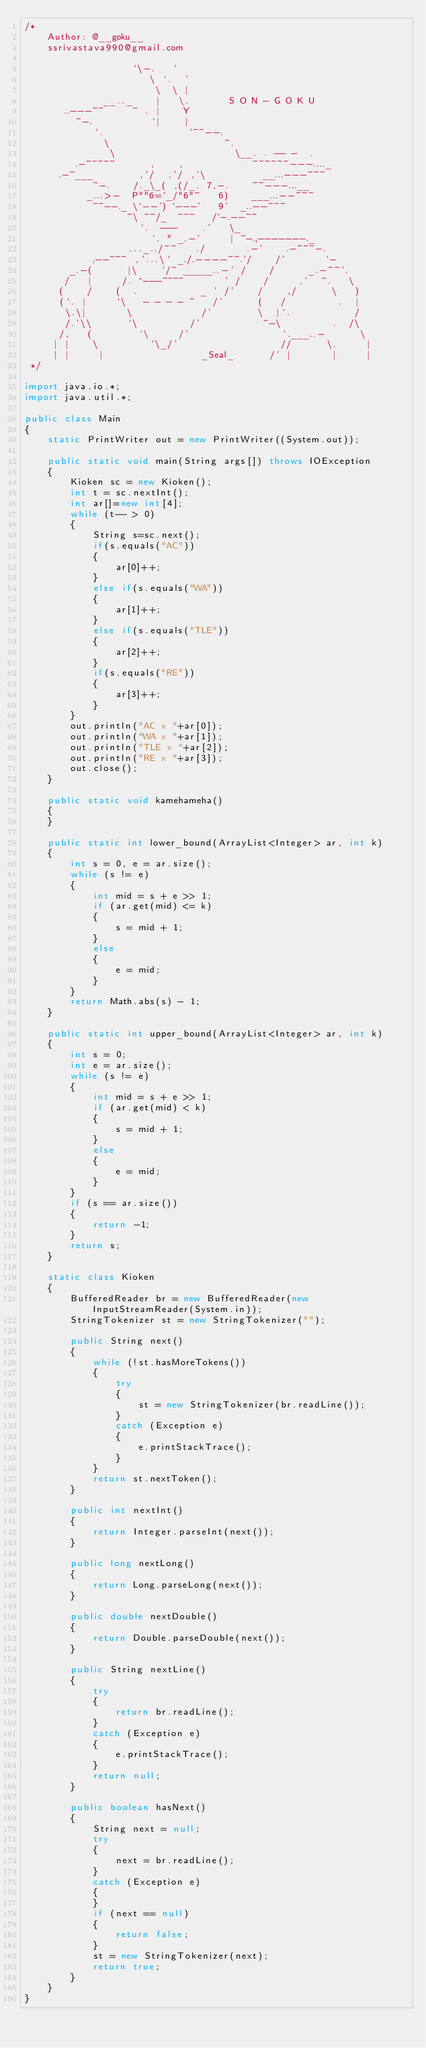Convert code to text. <code><loc_0><loc_0><loc_500><loc_500><_Java_>/*
    Author: @__goku__
    ssrivastava990@gmail.com

                   `\-.   `
                      \ `.  `
                       \  \ |
              __.._    |   \.       S O N - G O K U
       ..---~~     ~ . |    Y
         ~-.          `|    |
            `.               `~~--.
              \                    ~.
               \                     \__. . -- -  .
         .-~~~~~      ,    ,            ~~~~~~---...._
      .-~___        ,'/  ,'/ ,'\          __...---~~~
            ~-.    /._\_( ,(/_. 7,-.    ~~---...__
           _...>-  P""6=`_/"6"~   6)    ___...--~~~
            ~~--._ \`--') `---'   9'  _..--~~~
                  ~\ ~~/_  ~~~   /`-.--~~
                    `.  ---    .'   \_
                      `. " _.-'     | ~-.,-------._
                  ..._../~~   ./       .-'    .-~~~-.
            ,--~~~ ,'...\` _./.----~~.'/    /'       `-
        _.-(      |\    `/~ _____..-' /    /      _.-~~`.
       /   |     /. ^---~~~~       ' /    /     ,'  ~.   \
      (    /    (  .           _ ' /'    /    ,/      \   )
      (`. |     `\   - - - - ~   /'      (   /         .  |
       \.\|       \            /'        \  |`.           /
       /.'\\      `\         /'           ~-\         .  /\
      /,   (        `\     /'                `.___..-      \
     | |    \         `\_/'                  //      \.     |
     | |     |                 _Seal_      /' |       |     |
 */

import java.io.*;
import java.util.*;

public class Main
{
    static PrintWriter out = new PrintWriter((System.out));

    public static void main(String args[]) throws IOException
    {
        Kioken sc = new Kioken();
        int t = sc.nextInt();
        int ar[]=new int[4];
        while (t-- > 0)
        {
            String s=sc.next();
            if(s.equals("AC"))
            {
                ar[0]++;
            }
            else if(s.equals("WA"))
            {
                ar[1]++;
            }
            else if(s.equals("TLE"))
            {
                ar[2]++;
            }
            if(s.equals("RE"))
            {
                ar[3]++;
            }
        }
        out.println("AC x "+ar[0]);
        out.println("WA x "+ar[1]);
        out.println("TLE x "+ar[2]);
        out.println("RE x "+ar[3]);
        out.close();
    }

    public static void kamehameha()
    {
    }

    public static int lower_bound(ArrayList<Integer> ar, int k)
    {
        int s = 0, e = ar.size();
        while (s != e)
        {
            int mid = s + e >> 1;
            if (ar.get(mid) <= k)
            {
                s = mid + 1;
            }
            else
            {
                e = mid;
            }
        }
        return Math.abs(s) - 1;
    }

    public static int upper_bound(ArrayList<Integer> ar, int k)
    {
        int s = 0;
        int e = ar.size();
        while (s != e)
        {
            int mid = s + e >> 1;
            if (ar.get(mid) < k)
            {
                s = mid + 1;
            }
            else
            {
                e = mid;
            }
        }
        if (s == ar.size())
        {
            return -1;
        }
        return s;
    }

    static class Kioken
    {
        BufferedReader br = new BufferedReader(new InputStreamReader(System.in));
        StringTokenizer st = new StringTokenizer("");

        public String next()
        {
            while (!st.hasMoreTokens())
            {
                try
                {
                    st = new StringTokenizer(br.readLine());
                }
                catch (Exception e)
                {
                    e.printStackTrace();
                }
            }
            return st.nextToken();
        }

        public int nextInt()
        {
            return Integer.parseInt(next());
        }

        public long nextLong()
        {
            return Long.parseLong(next());
        }

        public double nextDouble()
        {
            return Double.parseDouble(next());
        }

        public String nextLine()
        {
            try
            {
                return br.readLine();
            }
            catch (Exception e)
            {
                e.printStackTrace();
            }
            return null;
        }

        public boolean hasNext()
        {
            String next = null;
            try
            {
                next = br.readLine();
            }
            catch (Exception e)
            {
            }
            if (next == null)
            {
                return false;
            }
            st = new StringTokenizer(next);
            return true;
        }
    }
}</code> 